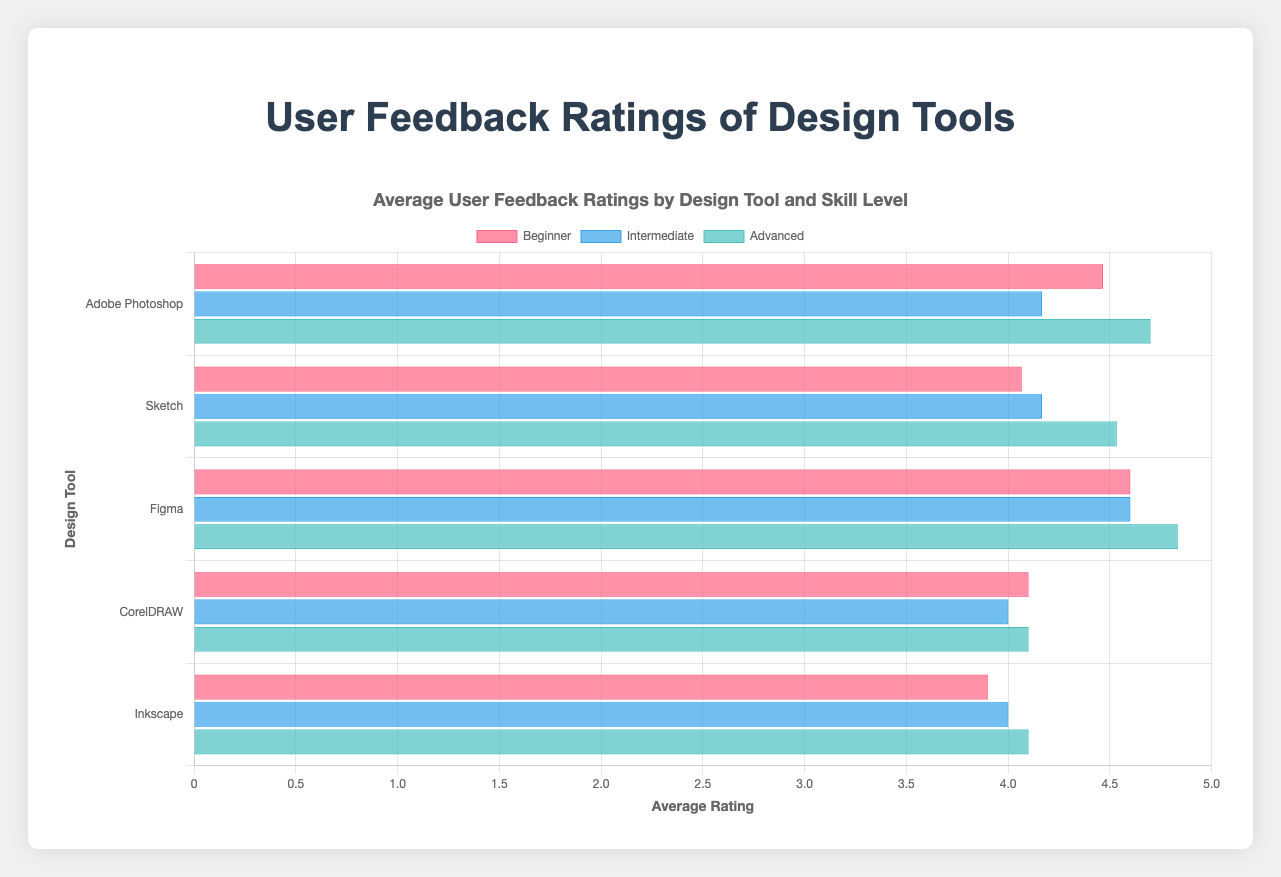Which design tool has the highest average rating for beginners? Look at the "Beginner" bars for each design tool. The longest bar indicates the highest rating. Figma has the highest average rating for beginners.
Answer: Figma Which age group and skill level combination gave Adobe Photoshop the highest rating? Examine the bars for Adobe Photoshop across different age groups and skill levels. The highest bar indicates the highest rating. Advanced users in the 18-25 age group gave the highest rating.
Answer: 18-25 Advanced How do the ratings for CorelDRAW compare between beginners and advanced users in the 26-35 age group? Check the bars for CorelDRAW in the 26-35 age group for both "Beginner" and "Advanced" levels. The heights of these bars indicate the ratings. The "Beginner" rating (4.2) is slightly higher than the "Advanced" rating (4.1).
Answer: Beginner higher than Advanced What is the difference between the highest and lowest ratings given to Sketch by any age group? Identify the highest and lowest bars for Sketch. The highest rating is 4.6 (Advanced, 26-35) and the lowest rating is 4.0 (Beginner, 18-25 and 36-45). The difference is 4.6 - 4.0 = 0.6.
Answer: 0.6 For the age group 36-45, which design tool has the lowest rating for intermediate users? Compare the intermediate bars for each design tool in the 36-45 age group. The shortest bar indicates the lowest rating. Adobe Photoshop has the lowest rating of 4.0.
Answer: Adobe Photoshop Is there any design tool that received above-average ratings (>4) from all skill levels across all age groups? Check the ratings for all skill levels for each design tool. Figma is the only tool with all ratings above 4 from beginners, intermediate, and advanced users across all age groups.
Answer: Figma Between Adobe Photoshop and Sketch, which design tool has higher ratings from advanced users in the 18-25 age group? Compare the advanced bars for Adobe Photoshop and Sketch in the 18-25 age group. The height of the bars indicates the ratings. Adobe Photoshop has a higher rating of 4.8 compared to Sketch’s 4.5.
Answer: Adobe Photoshop What is the combined average rating for beginner users across all design tools? Sum the beginner ratings for all design tools and divide by the number of tools. (4.5+4.6+4.3+4.0+4.2+4.0+4.7+4.6+4.5+4.1+4.2+4.0+3.8+3.9+4.0) / 15 = 63.9 / 15 = 4.26
Answer: 4.26 Which design tool has the most consistent ratings across different skill levels? Compare the difference between the highest and lowest ratings for each skill level for all tools. Figma has the smallest difference (4.9 - 4.5 = 0.4), making it the most consistent.
Answer: Figma 